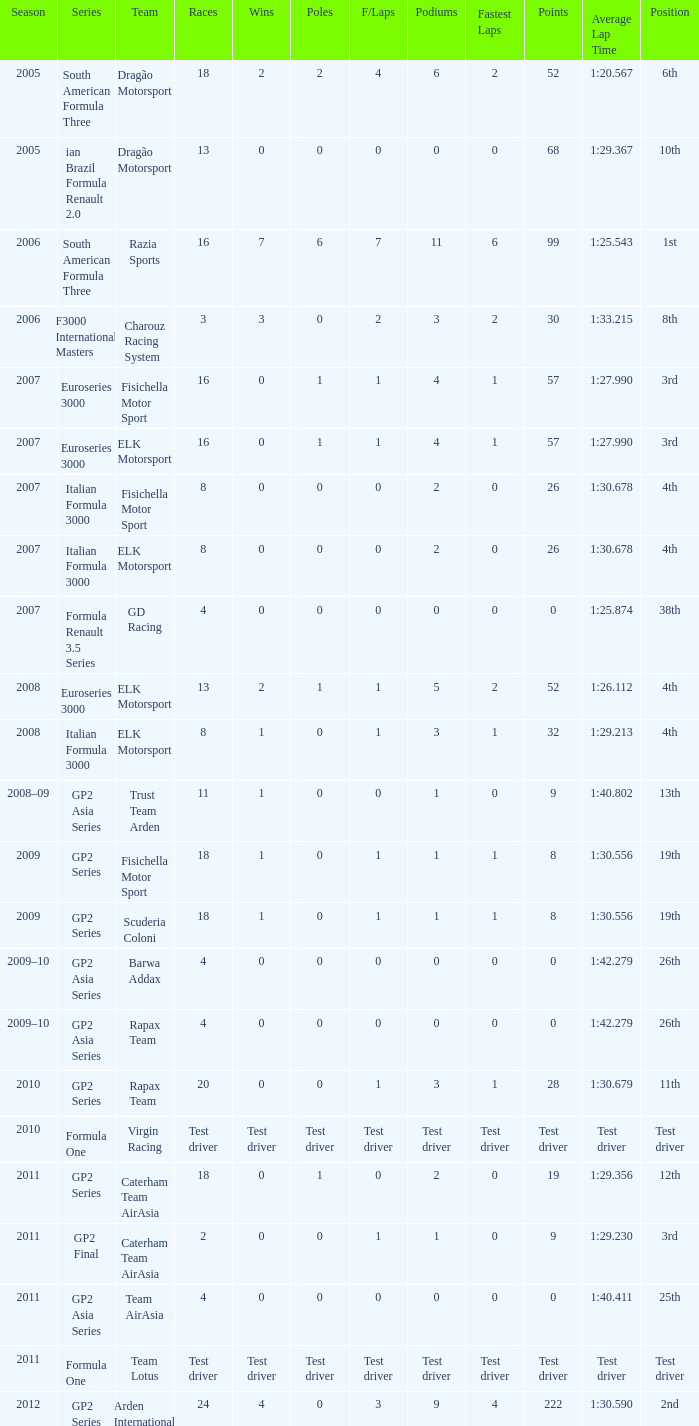In which season did he have 0 Poles and 19th position in the GP2 Series? 2009, 2009. 